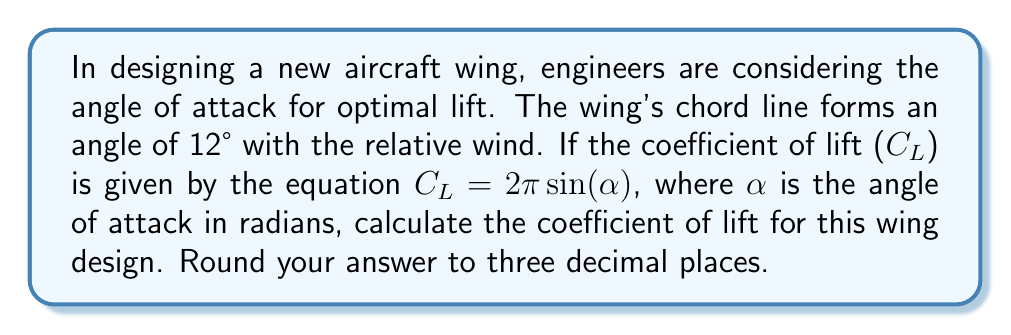Can you solve this math problem? To solve this problem, we'll follow these steps:

1) First, we need to convert the angle from degrees to radians, as the sine function in the equation uses radians.

   $\alpha = 12° \times \frac{\pi}{180°} = 0.2094$ radians

2) Now we can substitute this value into the given equation:

   $C_L = 2\pi \sin(\alpha)$

3) Let's substitute the value of $\alpha$:

   $C_L = 2\pi \sin(0.2094)$

4) Calculate the sine of 0.2094:

   $\sin(0.2094) \approx 0.2079$

5) Now multiply by $2\pi$:

   $C_L = 2\pi \times 0.2079 \approx 1.3064$

6) Rounding to three decimal places:

   $C_L \approx 1.306$

This coefficient of lift indicates the wing's ability to generate lift at this particular angle of attack. As a former pilot, you would recognize that this value is within a typical range for aircraft wings during normal flight conditions.
Answer: $C_L \approx 1.306$ 